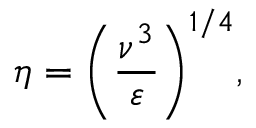<formula> <loc_0><loc_0><loc_500><loc_500>\eta = { { \left ( \frac { { { \nu } ^ { 3 } } } { \varepsilon } \right ) } ^ { 1 / 4 } } ,</formula> 